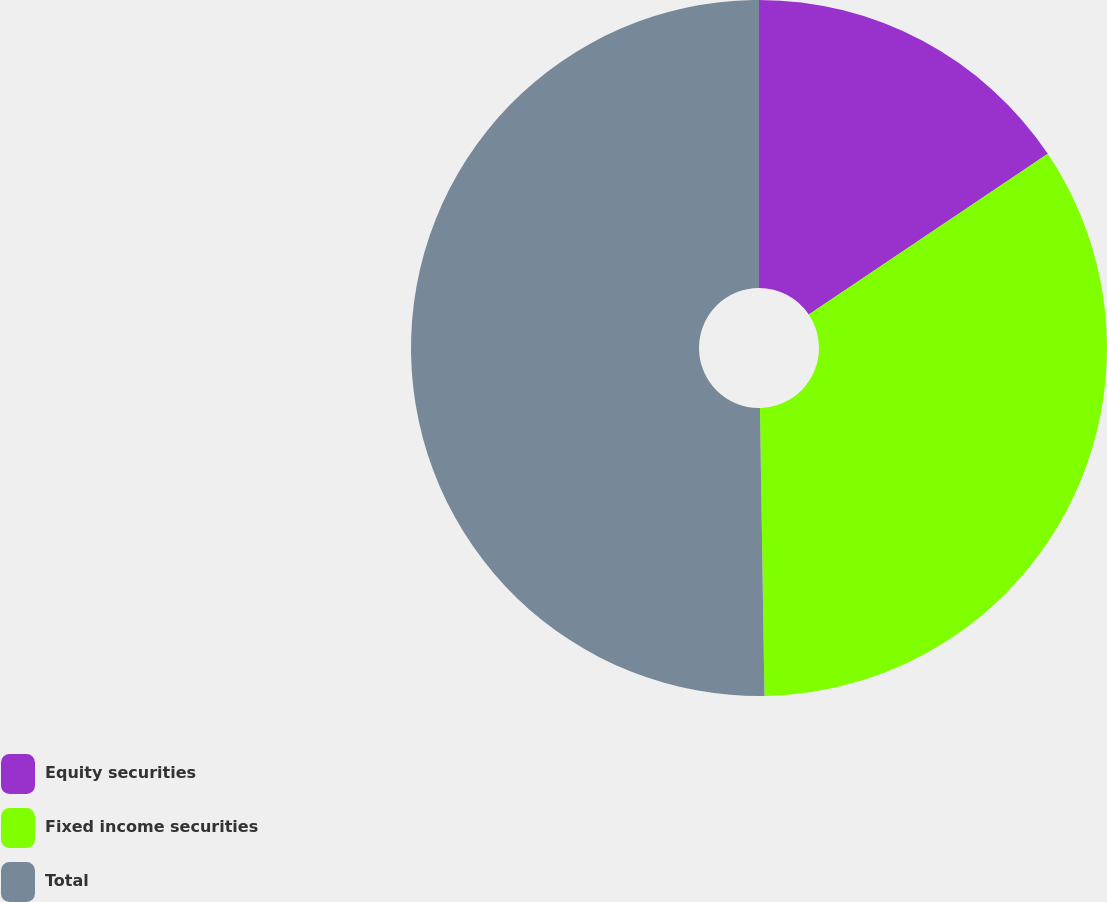<chart> <loc_0><loc_0><loc_500><loc_500><pie_chart><fcel>Equity securities<fcel>Fixed income securities<fcel>Total<nl><fcel>15.58%<fcel>34.17%<fcel>50.25%<nl></chart> 